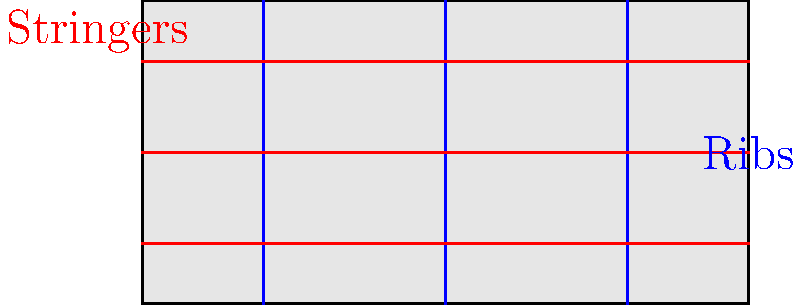In the composite aircraft panel shown above, which topology optimization strategy would most effectively increase the strength-to-weight ratio? Consider the current arrangement of ribs (vertical, blue) and stringers (horizontal, red). To optimize the internal structure of a composite aircraft panel for maximum strength-to-weight ratio, we need to consider several factors:

1. Load distribution: The panel experiences various loads during flight, including compression, tension, and shear.

2. Material properties: Composite materials are typically stronger in the direction of their fibers.

3. Buckling resistance: The internal structure helps prevent buckling under compressive loads.

4. Weight considerations: Adding more structural elements increases strength but also adds weight.

Given these factors, we can analyze the current topology and propose an optimization strategy:

1. Current layout:
   - Evenly spaced ribs (vertical)
   - Evenly spaced stringers (horizontal)

2. Optimization strategies:
   a) Variable spacing: Increase the density of ribs and stringers in high-stress areas.
   b) Orientation: Align some structural elements with principal stress directions.
   c) Curved or angled elements: Introduce non-linear elements to better distribute loads.
   d) Thickness variation: Use thicker elements in high-stress regions.

3. Most effective strategy:
   The most effective approach would be to implement a combination of variable spacing and orientation optimization. This can be achieved by:
   - Increasing the density of ribs and stringers near the panel edges and corners where stress concentrations occur.
   - Introducing diagonal or curved elements to better distribute loads and increase shear strength.
   - Maintaining some horizontal and vertical elements for buckling resistance and ease of manufacturing.

4. Rationale:
   - Variable spacing addresses local stress concentrations without significantly increasing overall weight.
   - Orientation optimization aligns structural elements with principal stress directions, improving load-carrying efficiency.
   - This combined approach maximizes strength in critical areas while minimizing unnecessary weight addition.

5. Implementation:
   The optimized topology would feature:
   - Denser rib and stringer spacing near panel edges and corners.
   - Diagonal or curved elements, particularly in the central region.
   - Reduced spacing of horizontal and vertical elements in lower-stress areas.

This strategy effectively increases the strength-to-weight ratio by optimizing material placement based on stress distribution, while considering manufacturing constraints and overall weight.
Answer: Variable spacing and orientation optimization 